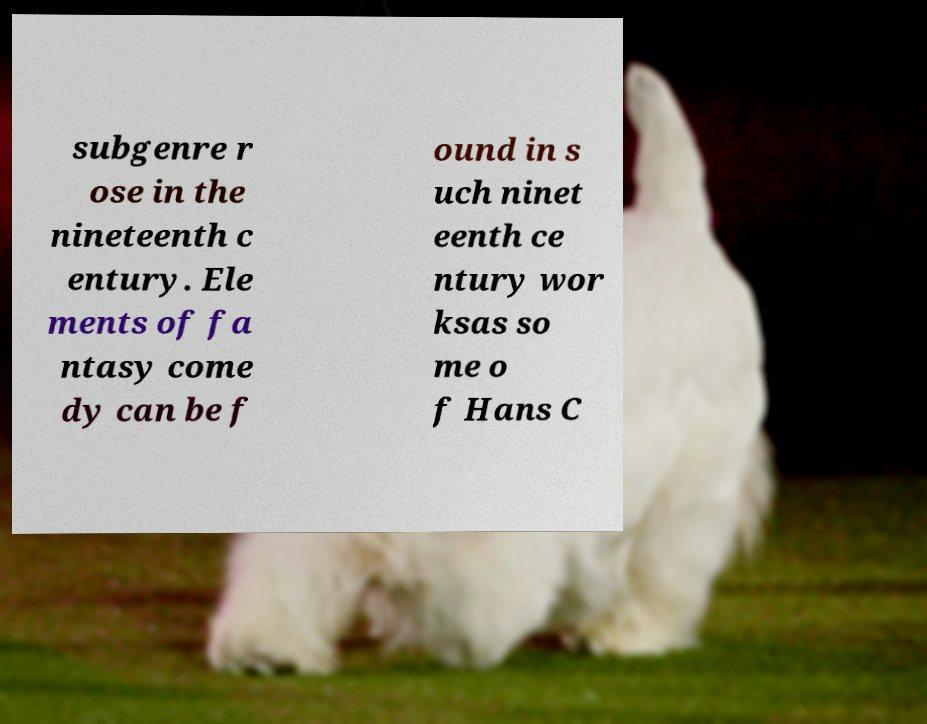What messages or text are displayed in this image? I need them in a readable, typed format. subgenre r ose in the nineteenth c entury. Ele ments of fa ntasy come dy can be f ound in s uch ninet eenth ce ntury wor ksas so me o f Hans C 